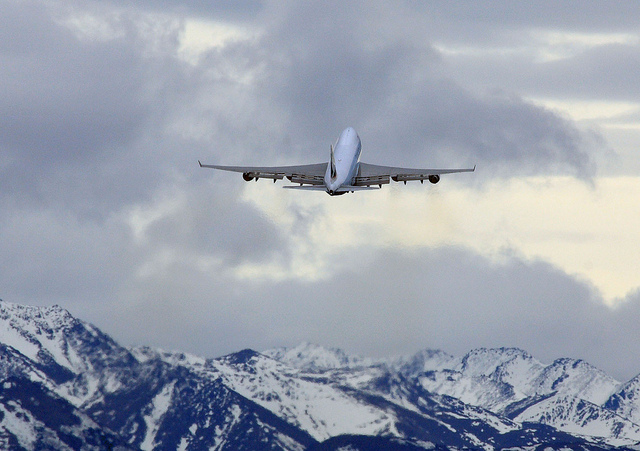What type of vehicle is in the image? The image shows an airplane, identified by its aerodynamic shape, wings, and jet engines, flying in the sky. 